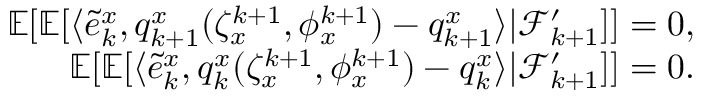<formula> <loc_0><loc_0><loc_500><loc_500>\begin{array} { r } { \mathbb { E } [ \mathbb { E } [ \langle \tilde { e } _ { k } ^ { x } , q _ { k + 1 } ^ { x } ( \zeta _ { x } ^ { k + 1 } , \phi _ { x } ^ { k + 1 } ) - q _ { k + 1 } ^ { x } \rangle | \mathcal { F } _ { k + 1 } ^ { \prime } ] ] = 0 , } \\ { \mathbb { E } [ \mathbb { E } [ \langle \tilde { e } _ { k } ^ { x } , q _ { k } ^ { x } ( \zeta _ { x } ^ { k + 1 } , \phi _ { x } ^ { k + 1 } ) - q _ { k } ^ { x } \rangle | \mathcal { F } _ { k + 1 } ^ { \prime } ] ] = 0 . } \end{array}</formula> 